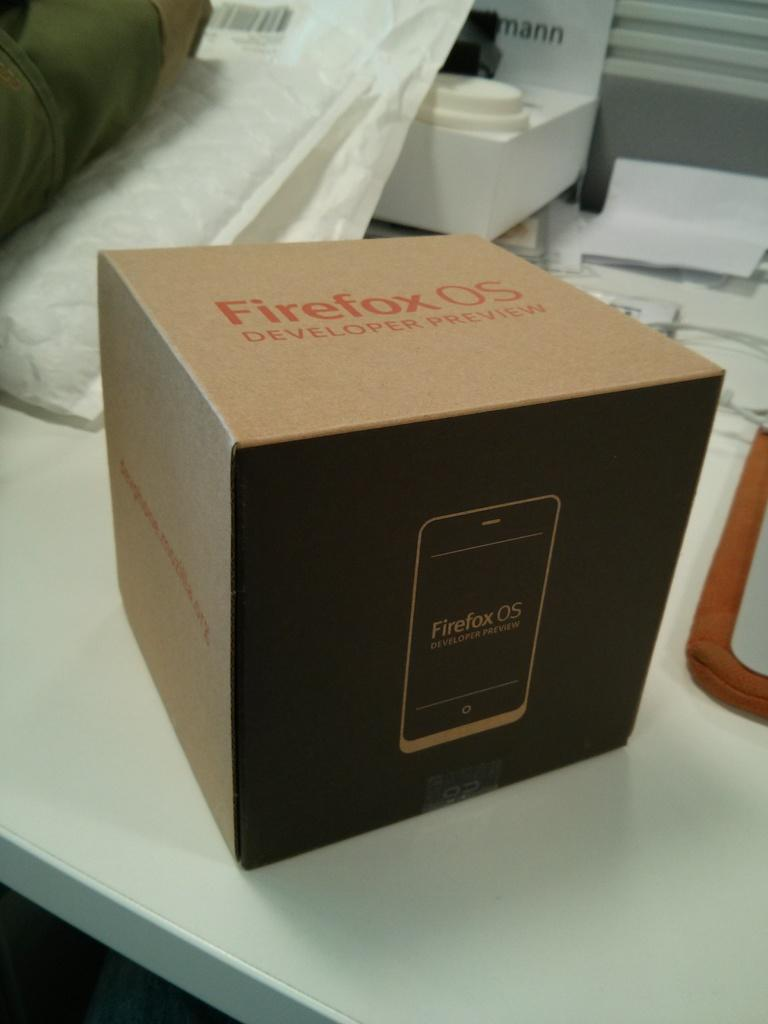Provide a one-sentence caption for the provided image. A Firefox OS box is on a white table. 